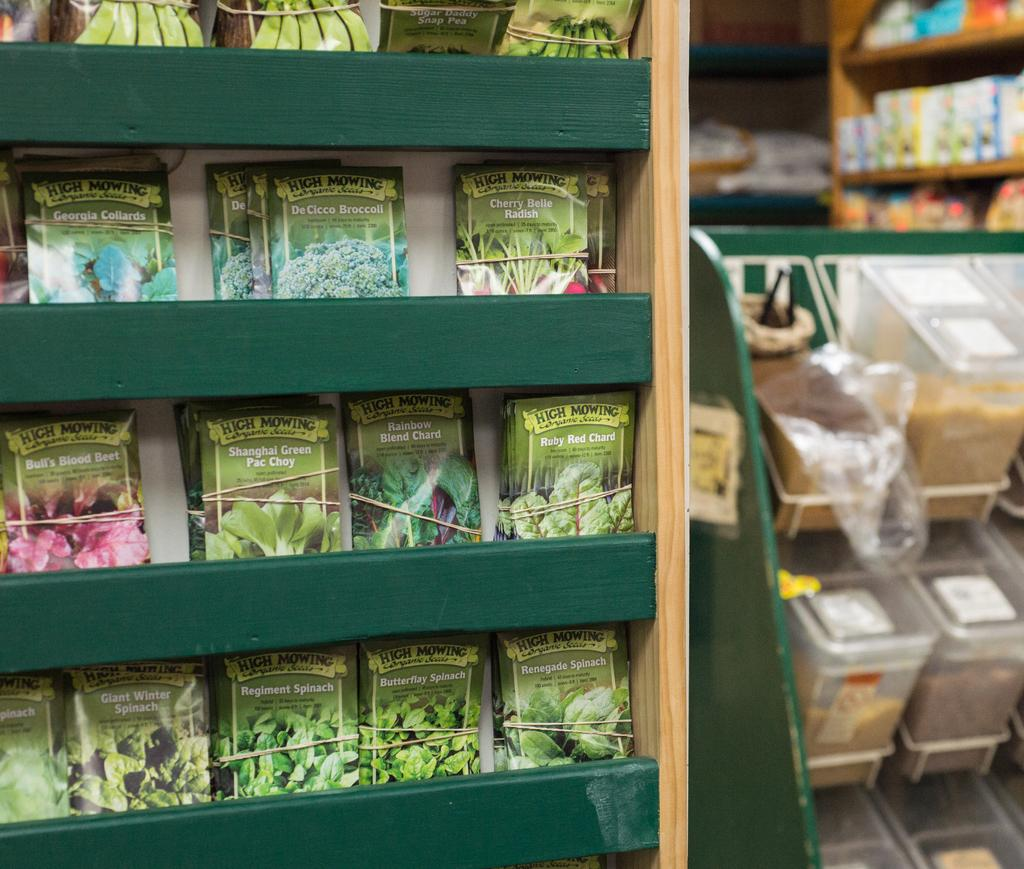Provide a one-sentence caption for the provided image. A pack of High Mowing seeds are lined up in a grocery store isle. 